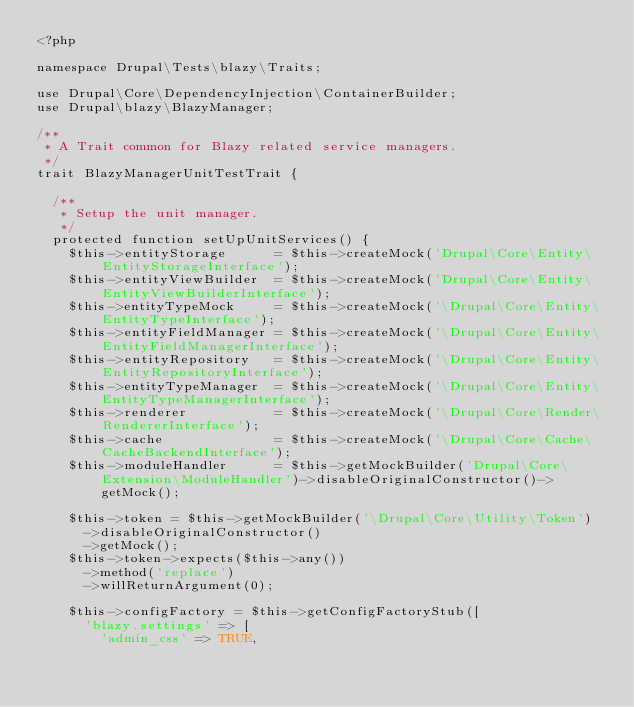<code> <loc_0><loc_0><loc_500><loc_500><_PHP_><?php

namespace Drupal\Tests\blazy\Traits;

use Drupal\Core\DependencyInjection\ContainerBuilder;
use Drupal\blazy\BlazyManager;

/**
 * A Trait common for Blazy related service managers.
 */
trait BlazyManagerUnitTestTrait {

  /**
   * Setup the unit manager.
   */
  protected function setUpUnitServices() {
    $this->entityStorage      = $this->createMock('Drupal\Core\Entity\EntityStorageInterface');
    $this->entityViewBuilder  = $this->createMock('Drupal\Core\Entity\EntityViewBuilderInterface');
    $this->entityTypeMock     = $this->createMock('\Drupal\Core\Entity\EntityTypeInterface');
    $this->entityFieldManager = $this->createMock('\Drupal\Core\Entity\EntityFieldManagerInterface');
    $this->entityRepository   = $this->createMock('\Drupal\Core\Entity\EntityRepositoryInterface');
    $this->entityTypeManager  = $this->createMock('\Drupal\Core\Entity\EntityTypeManagerInterface');
    $this->renderer           = $this->createMock('\Drupal\Core\Render\RendererInterface');
    $this->cache              = $this->createMock('\Drupal\Core\Cache\CacheBackendInterface');
    $this->moduleHandler      = $this->getMockBuilder('Drupal\Core\Extension\ModuleHandler')->disableOriginalConstructor()->getMock();

    $this->token = $this->getMockBuilder('\Drupal\Core\Utility\Token')
      ->disableOriginalConstructor()
      ->getMock();
    $this->token->expects($this->any())
      ->method('replace')
      ->willReturnArgument(0);

    $this->configFactory = $this->getConfigFactoryStub([
      'blazy.settings' => [
        'admin_css' => TRUE,</code> 